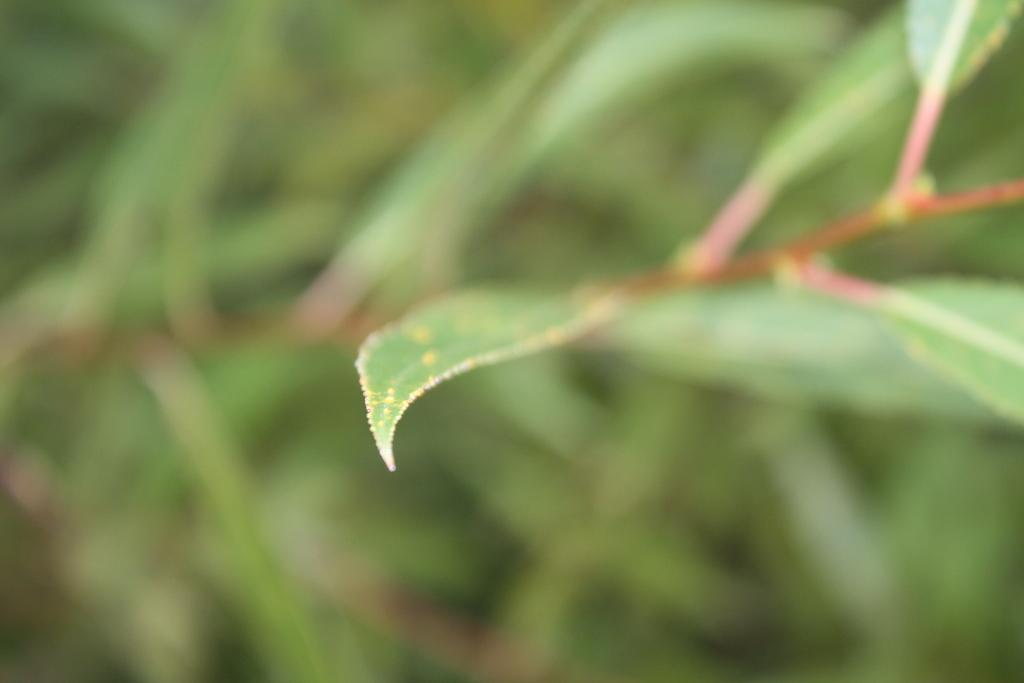What type of vegetation can be seen in the image? There are leaves in the image. Can you describe the background of the image? The background of the image is blurry. How many feet are visible in the image? There are no feet present in the image; it only features leaves and a blurry background. 